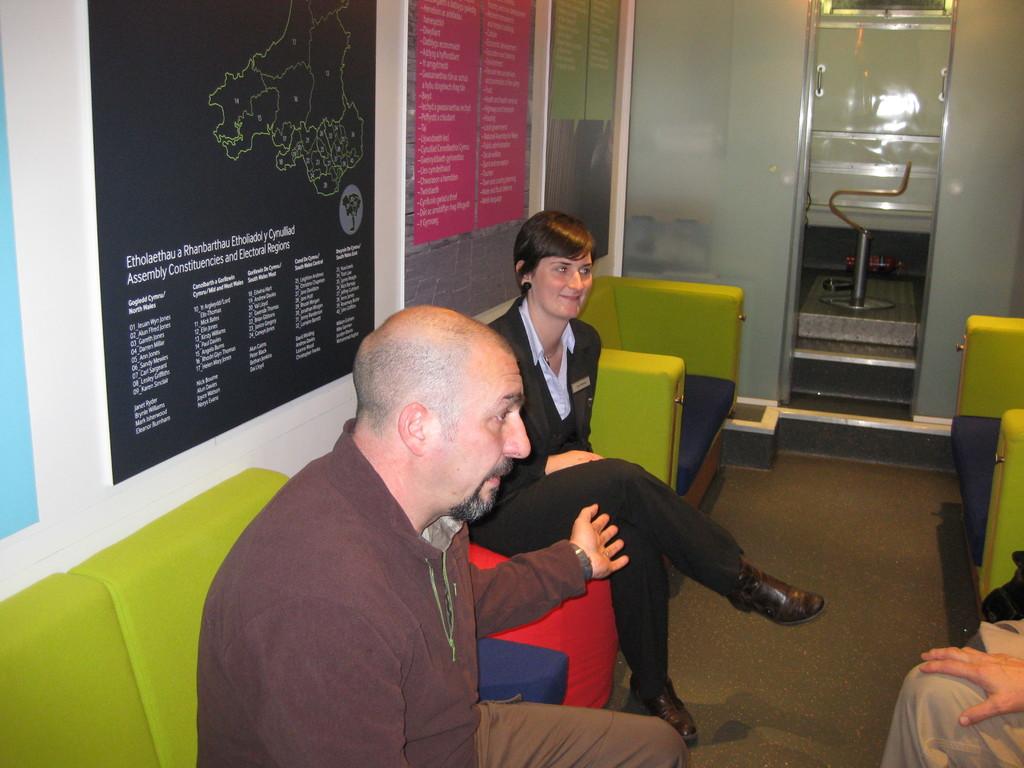On the black sign what does the first word say?
Provide a succinct answer. Etholaethau. 